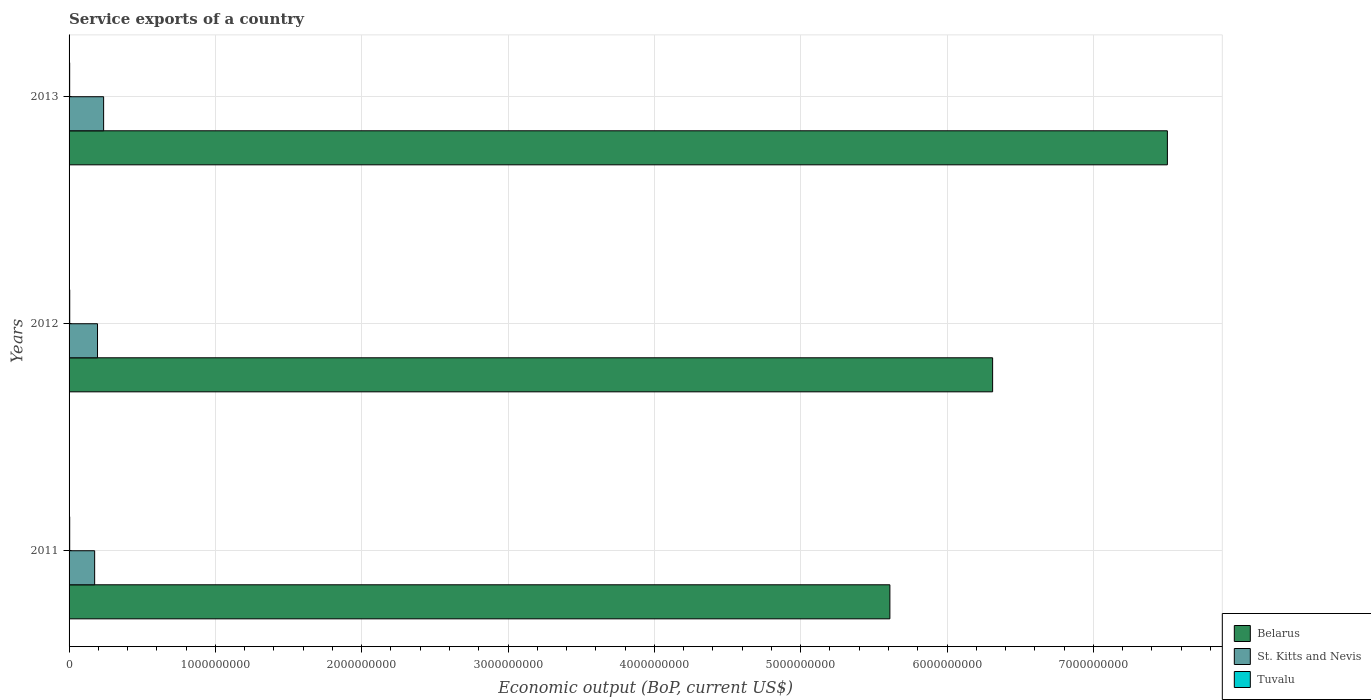How many different coloured bars are there?
Offer a terse response. 3. How many groups of bars are there?
Your response must be concise. 3. Are the number of bars per tick equal to the number of legend labels?
Your response must be concise. Yes. Are the number of bars on each tick of the Y-axis equal?
Give a very brief answer. Yes. How many bars are there on the 2nd tick from the bottom?
Give a very brief answer. 3. What is the label of the 3rd group of bars from the top?
Your answer should be compact. 2011. In how many cases, is the number of bars for a given year not equal to the number of legend labels?
Keep it short and to the point. 0. What is the service exports in Belarus in 2013?
Provide a succinct answer. 7.51e+09. Across all years, what is the maximum service exports in St. Kitts and Nevis?
Ensure brevity in your answer.  2.36e+08. Across all years, what is the minimum service exports in Belarus?
Keep it short and to the point. 5.61e+09. In which year was the service exports in St. Kitts and Nevis maximum?
Your response must be concise. 2013. In which year was the service exports in Tuvalu minimum?
Provide a succinct answer. 2013. What is the total service exports in Belarus in the graph?
Make the answer very short. 1.94e+1. What is the difference between the service exports in Tuvalu in 2012 and that in 2013?
Keep it short and to the point. 3.56e+05. What is the difference between the service exports in Belarus in 2013 and the service exports in Tuvalu in 2012?
Make the answer very short. 7.50e+09. What is the average service exports in Tuvalu per year?
Offer a terse response. 4.33e+06. In the year 2011, what is the difference between the service exports in St. Kitts and Nevis and service exports in Tuvalu?
Provide a succinct answer. 1.70e+08. In how many years, is the service exports in St. Kitts and Nevis greater than 7200000000 US$?
Keep it short and to the point. 0. What is the ratio of the service exports in Belarus in 2011 to that in 2013?
Give a very brief answer. 0.75. What is the difference between the highest and the second highest service exports in Tuvalu?
Ensure brevity in your answer.  1.48e+05. What is the difference between the highest and the lowest service exports in Tuvalu?
Your response must be concise. 3.56e+05. What does the 3rd bar from the top in 2011 represents?
Make the answer very short. Belarus. What does the 2nd bar from the bottom in 2011 represents?
Your response must be concise. St. Kitts and Nevis. How many years are there in the graph?
Offer a terse response. 3. What is the difference between two consecutive major ticks on the X-axis?
Your response must be concise. 1.00e+09. Are the values on the major ticks of X-axis written in scientific E-notation?
Your response must be concise. No. Does the graph contain any zero values?
Provide a succinct answer. No. How are the legend labels stacked?
Your response must be concise. Vertical. What is the title of the graph?
Give a very brief answer. Service exports of a country. Does "Belarus" appear as one of the legend labels in the graph?
Make the answer very short. Yes. What is the label or title of the X-axis?
Your answer should be very brief. Economic output (BoP, current US$). What is the label or title of the Y-axis?
Offer a very short reply. Years. What is the Economic output (BoP, current US$) of Belarus in 2011?
Keep it short and to the point. 5.61e+09. What is the Economic output (BoP, current US$) of St. Kitts and Nevis in 2011?
Provide a succinct answer. 1.75e+08. What is the Economic output (BoP, current US$) in Tuvalu in 2011?
Your answer should be compact. 4.35e+06. What is the Economic output (BoP, current US$) of Belarus in 2012?
Give a very brief answer. 6.31e+09. What is the Economic output (BoP, current US$) of St. Kitts and Nevis in 2012?
Give a very brief answer. 1.94e+08. What is the Economic output (BoP, current US$) of Tuvalu in 2012?
Keep it short and to the point. 4.49e+06. What is the Economic output (BoP, current US$) in Belarus in 2013?
Your answer should be very brief. 7.51e+09. What is the Economic output (BoP, current US$) in St. Kitts and Nevis in 2013?
Your answer should be very brief. 2.36e+08. What is the Economic output (BoP, current US$) of Tuvalu in 2013?
Offer a very short reply. 4.14e+06. Across all years, what is the maximum Economic output (BoP, current US$) in Belarus?
Your response must be concise. 7.51e+09. Across all years, what is the maximum Economic output (BoP, current US$) of St. Kitts and Nevis?
Your response must be concise. 2.36e+08. Across all years, what is the maximum Economic output (BoP, current US$) in Tuvalu?
Provide a short and direct response. 4.49e+06. Across all years, what is the minimum Economic output (BoP, current US$) in Belarus?
Keep it short and to the point. 5.61e+09. Across all years, what is the minimum Economic output (BoP, current US$) in St. Kitts and Nevis?
Give a very brief answer. 1.75e+08. Across all years, what is the minimum Economic output (BoP, current US$) of Tuvalu?
Offer a terse response. 4.14e+06. What is the total Economic output (BoP, current US$) of Belarus in the graph?
Give a very brief answer. 1.94e+1. What is the total Economic output (BoP, current US$) of St. Kitts and Nevis in the graph?
Offer a terse response. 6.05e+08. What is the total Economic output (BoP, current US$) in Tuvalu in the graph?
Provide a short and direct response. 1.30e+07. What is the difference between the Economic output (BoP, current US$) in Belarus in 2011 and that in 2012?
Give a very brief answer. -7.02e+08. What is the difference between the Economic output (BoP, current US$) of St. Kitts and Nevis in 2011 and that in 2012?
Keep it short and to the point. -1.96e+07. What is the difference between the Economic output (BoP, current US$) of Tuvalu in 2011 and that in 2012?
Your answer should be very brief. -1.48e+05. What is the difference between the Economic output (BoP, current US$) in Belarus in 2011 and that in 2013?
Your response must be concise. -1.90e+09. What is the difference between the Economic output (BoP, current US$) of St. Kitts and Nevis in 2011 and that in 2013?
Your answer should be very brief. -6.13e+07. What is the difference between the Economic output (BoP, current US$) of Tuvalu in 2011 and that in 2013?
Make the answer very short. 2.08e+05. What is the difference between the Economic output (BoP, current US$) of Belarus in 2012 and that in 2013?
Offer a very short reply. -1.19e+09. What is the difference between the Economic output (BoP, current US$) in St. Kitts and Nevis in 2012 and that in 2013?
Provide a succinct answer. -4.17e+07. What is the difference between the Economic output (BoP, current US$) of Tuvalu in 2012 and that in 2013?
Your answer should be very brief. 3.56e+05. What is the difference between the Economic output (BoP, current US$) in Belarus in 2011 and the Economic output (BoP, current US$) in St. Kitts and Nevis in 2012?
Your answer should be compact. 5.42e+09. What is the difference between the Economic output (BoP, current US$) of Belarus in 2011 and the Economic output (BoP, current US$) of Tuvalu in 2012?
Keep it short and to the point. 5.61e+09. What is the difference between the Economic output (BoP, current US$) in St. Kitts and Nevis in 2011 and the Economic output (BoP, current US$) in Tuvalu in 2012?
Offer a very short reply. 1.70e+08. What is the difference between the Economic output (BoP, current US$) in Belarus in 2011 and the Economic output (BoP, current US$) in St. Kitts and Nevis in 2013?
Provide a succinct answer. 5.37e+09. What is the difference between the Economic output (BoP, current US$) in Belarus in 2011 and the Economic output (BoP, current US$) in Tuvalu in 2013?
Your answer should be very brief. 5.61e+09. What is the difference between the Economic output (BoP, current US$) of St. Kitts and Nevis in 2011 and the Economic output (BoP, current US$) of Tuvalu in 2013?
Your response must be concise. 1.71e+08. What is the difference between the Economic output (BoP, current US$) in Belarus in 2012 and the Economic output (BoP, current US$) in St. Kitts and Nevis in 2013?
Your response must be concise. 6.08e+09. What is the difference between the Economic output (BoP, current US$) of Belarus in 2012 and the Economic output (BoP, current US$) of Tuvalu in 2013?
Keep it short and to the point. 6.31e+09. What is the difference between the Economic output (BoP, current US$) of St. Kitts and Nevis in 2012 and the Economic output (BoP, current US$) of Tuvalu in 2013?
Your response must be concise. 1.90e+08. What is the average Economic output (BoP, current US$) in Belarus per year?
Make the answer very short. 6.48e+09. What is the average Economic output (BoP, current US$) in St. Kitts and Nevis per year?
Provide a short and direct response. 2.02e+08. What is the average Economic output (BoP, current US$) of Tuvalu per year?
Give a very brief answer. 4.33e+06. In the year 2011, what is the difference between the Economic output (BoP, current US$) of Belarus and Economic output (BoP, current US$) of St. Kitts and Nevis?
Provide a succinct answer. 5.43e+09. In the year 2011, what is the difference between the Economic output (BoP, current US$) of Belarus and Economic output (BoP, current US$) of Tuvalu?
Your answer should be very brief. 5.61e+09. In the year 2011, what is the difference between the Economic output (BoP, current US$) in St. Kitts and Nevis and Economic output (BoP, current US$) in Tuvalu?
Provide a short and direct response. 1.70e+08. In the year 2012, what is the difference between the Economic output (BoP, current US$) of Belarus and Economic output (BoP, current US$) of St. Kitts and Nevis?
Make the answer very short. 6.12e+09. In the year 2012, what is the difference between the Economic output (BoP, current US$) in Belarus and Economic output (BoP, current US$) in Tuvalu?
Offer a terse response. 6.31e+09. In the year 2012, what is the difference between the Economic output (BoP, current US$) in St. Kitts and Nevis and Economic output (BoP, current US$) in Tuvalu?
Offer a terse response. 1.90e+08. In the year 2013, what is the difference between the Economic output (BoP, current US$) of Belarus and Economic output (BoP, current US$) of St. Kitts and Nevis?
Offer a terse response. 7.27e+09. In the year 2013, what is the difference between the Economic output (BoP, current US$) of Belarus and Economic output (BoP, current US$) of Tuvalu?
Provide a short and direct response. 7.50e+09. In the year 2013, what is the difference between the Economic output (BoP, current US$) of St. Kitts and Nevis and Economic output (BoP, current US$) of Tuvalu?
Your answer should be compact. 2.32e+08. What is the ratio of the Economic output (BoP, current US$) of Belarus in 2011 to that in 2012?
Give a very brief answer. 0.89. What is the ratio of the Economic output (BoP, current US$) in St. Kitts and Nevis in 2011 to that in 2012?
Your answer should be compact. 0.9. What is the ratio of the Economic output (BoP, current US$) in Belarus in 2011 to that in 2013?
Make the answer very short. 0.75. What is the ratio of the Economic output (BoP, current US$) of St. Kitts and Nevis in 2011 to that in 2013?
Ensure brevity in your answer.  0.74. What is the ratio of the Economic output (BoP, current US$) in Tuvalu in 2011 to that in 2013?
Offer a terse response. 1.05. What is the ratio of the Economic output (BoP, current US$) in Belarus in 2012 to that in 2013?
Your response must be concise. 0.84. What is the ratio of the Economic output (BoP, current US$) of St. Kitts and Nevis in 2012 to that in 2013?
Give a very brief answer. 0.82. What is the ratio of the Economic output (BoP, current US$) of Tuvalu in 2012 to that in 2013?
Your response must be concise. 1.09. What is the difference between the highest and the second highest Economic output (BoP, current US$) of Belarus?
Provide a short and direct response. 1.19e+09. What is the difference between the highest and the second highest Economic output (BoP, current US$) in St. Kitts and Nevis?
Your response must be concise. 4.17e+07. What is the difference between the highest and the second highest Economic output (BoP, current US$) of Tuvalu?
Keep it short and to the point. 1.48e+05. What is the difference between the highest and the lowest Economic output (BoP, current US$) in Belarus?
Offer a terse response. 1.90e+09. What is the difference between the highest and the lowest Economic output (BoP, current US$) of St. Kitts and Nevis?
Provide a succinct answer. 6.13e+07. What is the difference between the highest and the lowest Economic output (BoP, current US$) of Tuvalu?
Provide a succinct answer. 3.56e+05. 